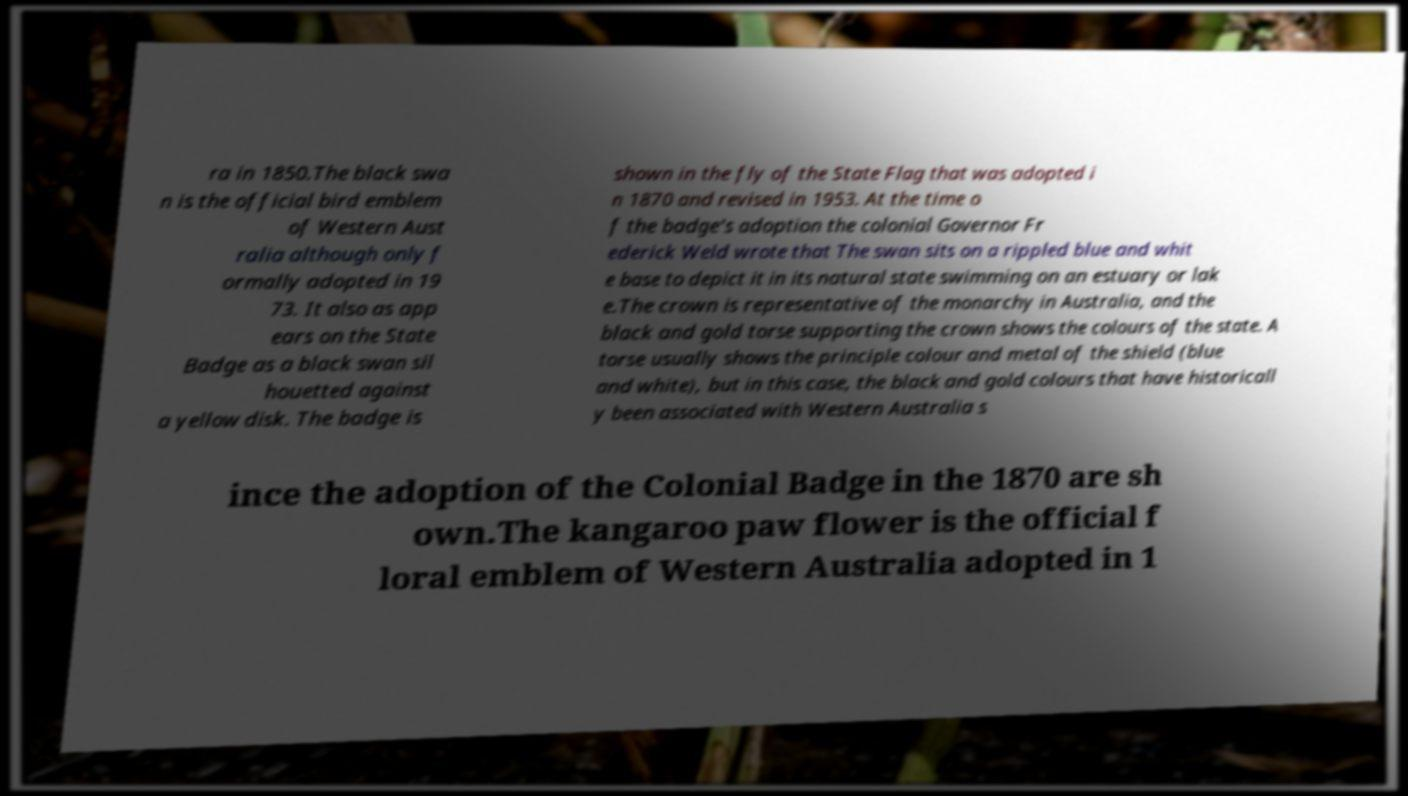Could you assist in decoding the text presented in this image and type it out clearly? ra in 1850.The black swa n is the official bird emblem of Western Aust ralia although only f ormally adopted in 19 73. It also as app ears on the State Badge as a black swan sil houetted against a yellow disk. The badge is shown in the fly of the State Flag that was adopted i n 1870 and revised in 1953. At the time o f the badge's adoption the colonial Governor Fr ederick Weld wrote that The swan sits on a rippled blue and whit e base to depict it in its natural state swimming on an estuary or lak e.The crown is representative of the monarchy in Australia, and the black and gold torse supporting the crown shows the colours of the state. A torse usually shows the principle colour and metal of the shield (blue and white), but in this case, the black and gold colours that have historicall y been associated with Western Australia s ince the adoption of the Colonial Badge in the 1870 are sh own.The kangaroo paw flower is the official f loral emblem of Western Australia adopted in 1 